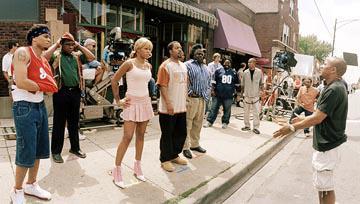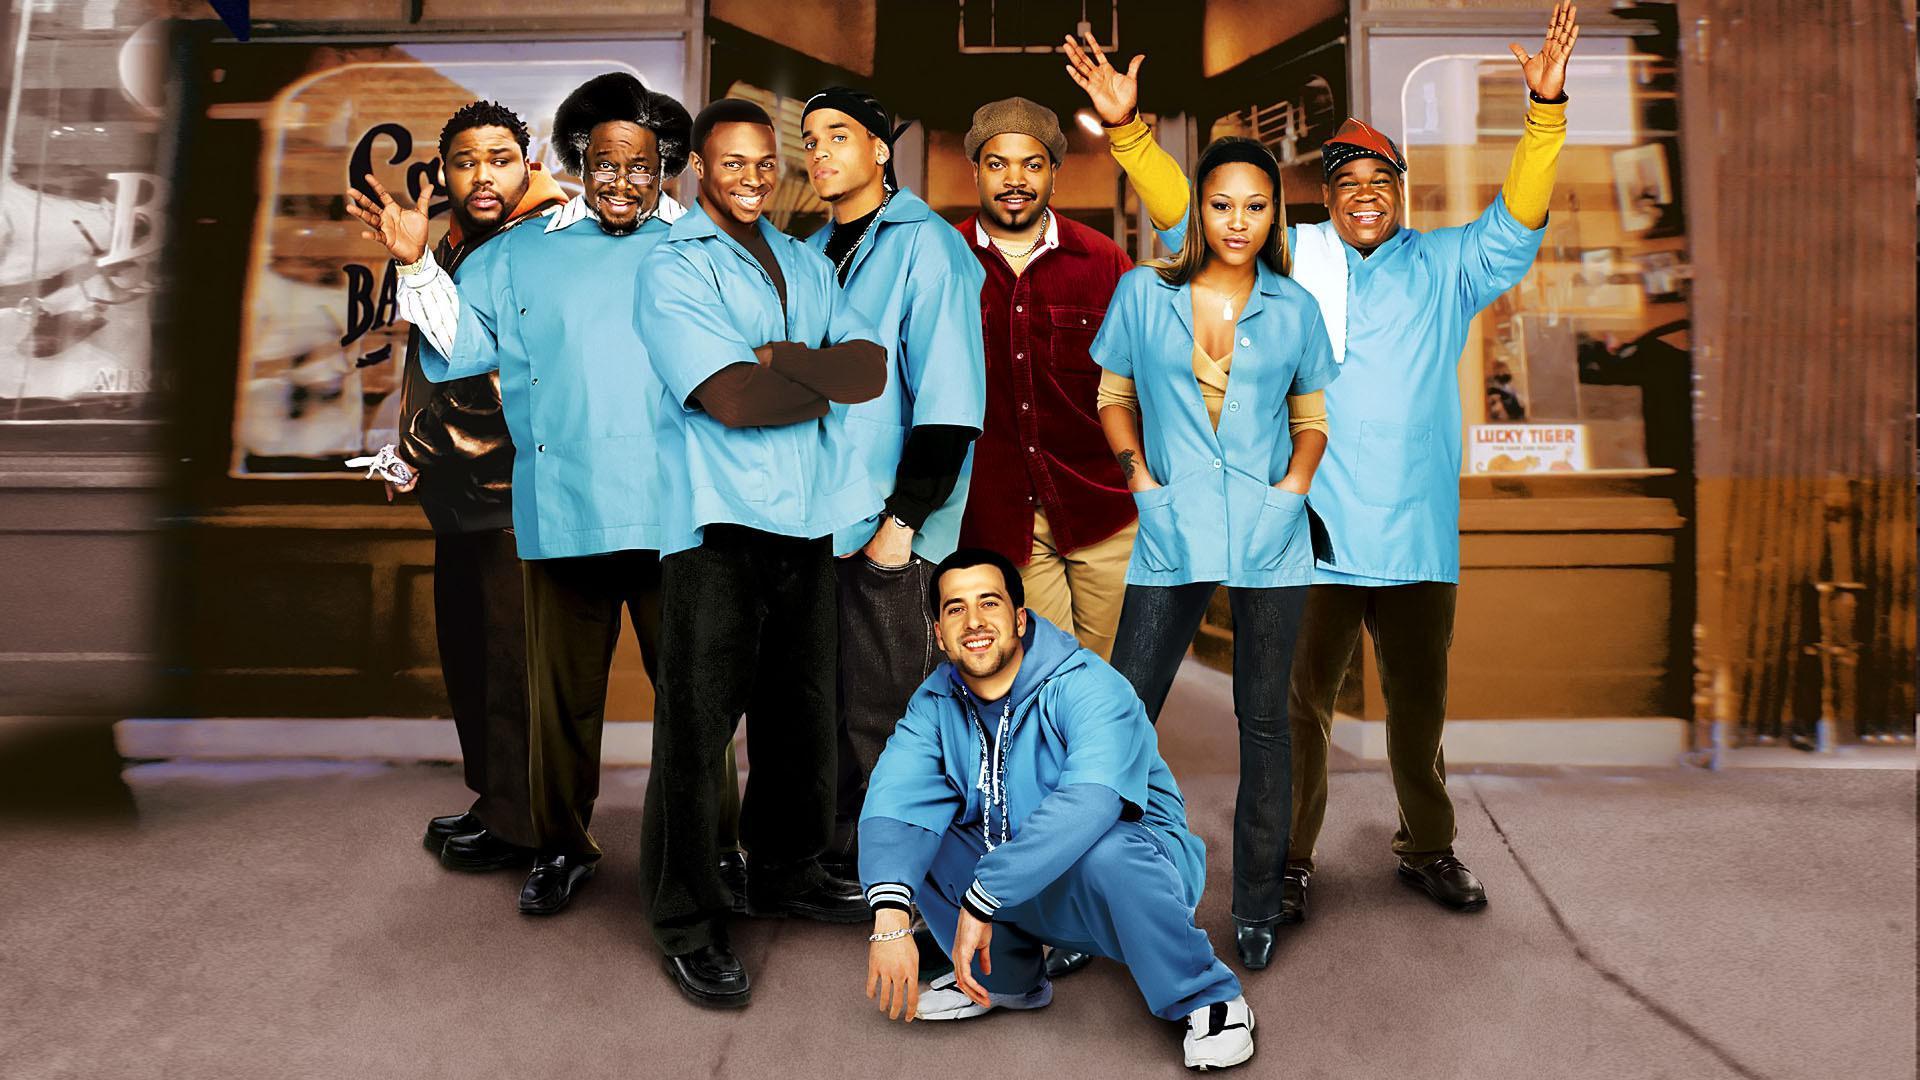The first image is the image on the left, the second image is the image on the right. Examine the images to the left and right. Is the description "The image on the right has no more than one person wearing a hat." accurate? Answer yes or no. No. The first image is the image on the left, the second image is the image on the right. For the images shown, is this caption "In one of the images, a man stands alone with no one else present." true? Answer yes or no. No. 